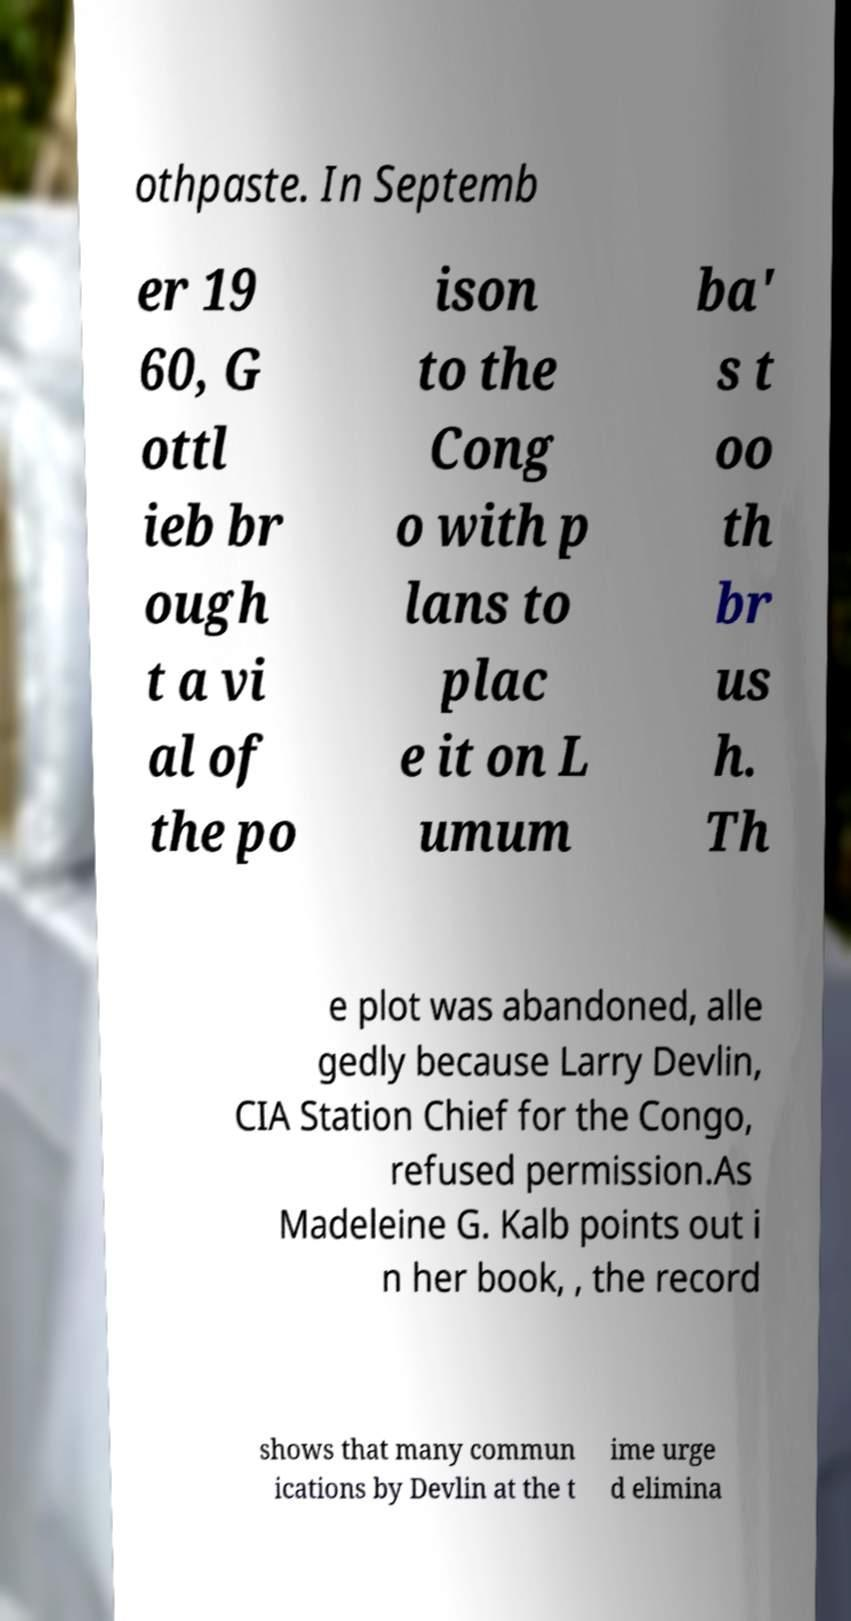Can you accurately transcribe the text from the provided image for me? othpaste. In Septemb er 19 60, G ottl ieb br ough t a vi al of the po ison to the Cong o with p lans to plac e it on L umum ba' s t oo th br us h. Th e plot was abandoned, alle gedly because Larry Devlin, CIA Station Chief for the Congo, refused permission.As Madeleine G. Kalb points out i n her book, , the record shows that many commun ications by Devlin at the t ime urge d elimina 